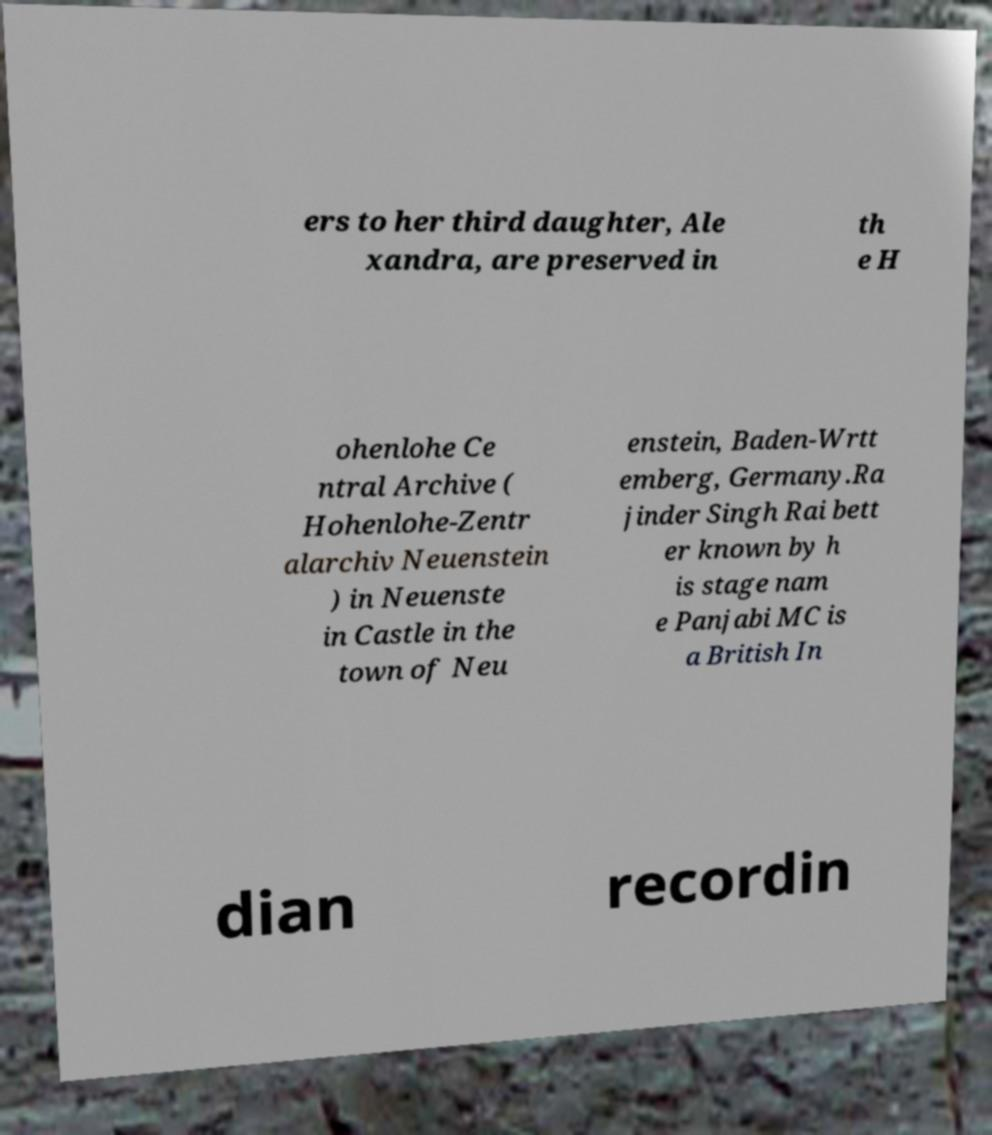Could you assist in decoding the text presented in this image and type it out clearly? ers to her third daughter, Ale xandra, are preserved in th e H ohenlohe Ce ntral Archive ( Hohenlohe-Zentr alarchiv Neuenstein ) in Neuenste in Castle in the town of Neu enstein, Baden-Wrtt emberg, Germany.Ra jinder Singh Rai bett er known by h is stage nam e Panjabi MC is a British In dian recordin 